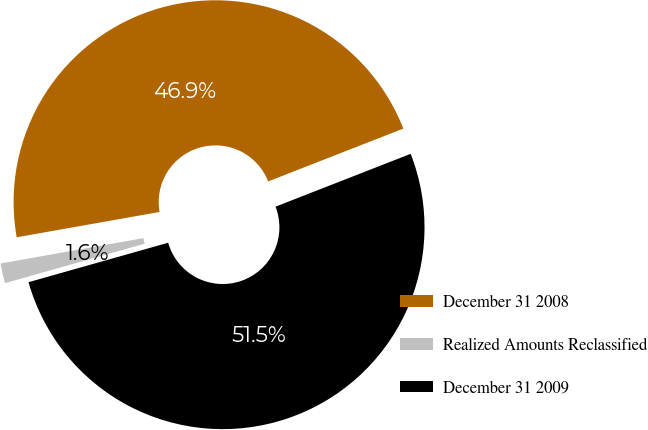Convert chart to OTSL. <chart><loc_0><loc_0><loc_500><loc_500><pie_chart><fcel>December 31 2008<fcel>Realized Amounts Reclassified<fcel>December 31 2009<nl><fcel>46.86%<fcel>1.59%<fcel>51.55%<nl></chart> 